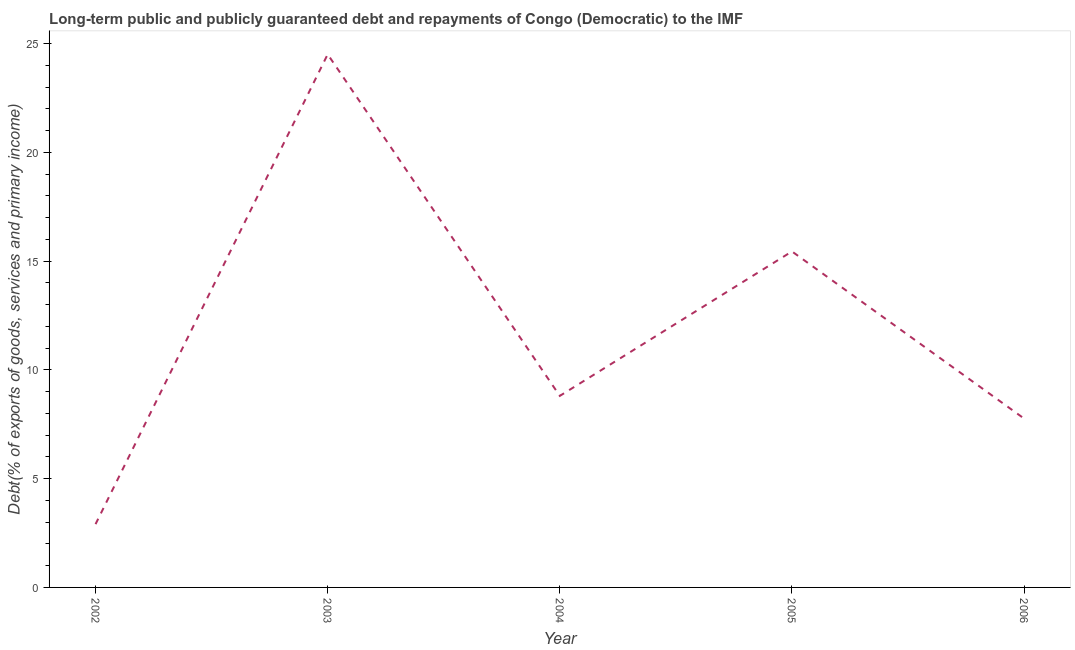What is the debt service in 2004?
Your answer should be very brief. 8.8. Across all years, what is the maximum debt service?
Offer a very short reply. 24.51. Across all years, what is the minimum debt service?
Keep it short and to the point. 2.91. In which year was the debt service maximum?
Your response must be concise. 2003. In which year was the debt service minimum?
Your response must be concise. 2002. What is the sum of the debt service?
Your answer should be compact. 59.43. What is the difference between the debt service in 2002 and 2004?
Offer a very short reply. -5.9. What is the average debt service per year?
Keep it short and to the point. 11.89. What is the median debt service?
Offer a very short reply. 8.8. In how many years, is the debt service greater than 3 %?
Your response must be concise. 4. Do a majority of the years between 2006 and 2002 (inclusive) have debt service greater than 4 %?
Provide a succinct answer. Yes. What is the ratio of the debt service in 2002 to that in 2006?
Your answer should be compact. 0.37. What is the difference between the highest and the second highest debt service?
Your answer should be very brief. 9.06. What is the difference between the highest and the lowest debt service?
Make the answer very short. 21.6. In how many years, is the debt service greater than the average debt service taken over all years?
Give a very brief answer. 2. Does the debt service monotonically increase over the years?
Keep it short and to the point. No. How many years are there in the graph?
Offer a very short reply. 5. What is the difference between two consecutive major ticks on the Y-axis?
Your answer should be compact. 5. Does the graph contain grids?
Make the answer very short. No. What is the title of the graph?
Your answer should be compact. Long-term public and publicly guaranteed debt and repayments of Congo (Democratic) to the IMF. What is the label or title of the Y-axis?
Keep it short and to the point. Debt(% of exports of goods, services and primary income). What is the Debt(% of exports of goods, services and primary income) in 2002?
Offer a very short reply. 2.91. What is the Debt(% of exports of goods, services and primary income) in 2003?
Your answer should be very brief. 24.51. What is the Debt(% of exports of goods, services and primary income) of 2004?
Your answer should be compact. 8.8. What is the Debt(% of exports of goods, services and primary income) in 2005?
Keep it short and to the point. 15.45. What is the Debt(% of exports of goods, services and primary income) of 2006?
Ensure brevity in your answer.  7.76. What is the difference between the Debt(% of exports of goods, services and primary income) in 2002 and 2003?
Provide a succinct answer. -21.6. What is the difference between the Debt(% of exports of goods, services and primary income) in 2002 and 2004?
Make the answer very short. -5.9. What is the difference between the Debt(% of exports of goods, services and primary income) in 2002 and 2005?
Keep it short and to the point. -12.54. What is the difference between the Debt(% of exports of goods, services and primary income) in 2002 and 2006?
Give a very brief answer. -4.85. What is the difference between the Debt(% of exports of goods, services and primary income) in 2003 and 2004?
Your answer should be very brief. 15.7. What is the difference between the Debt(% of exports of goods, services and primary income) in 2003 and 2005?
Make the answer very short. 9.06. What is the difference between the Debt(% of exports of goods, services and primary income) in 2003 and 2006?
Provide a succinct answer. 16.74. What is the difference between the Debt(% of exports of goods, services and primary income) in 2004 and 2005?
Keep it short and to the point. -6.64. What is the difference between the Debt(% of exports of goods, services and primary income) in 2004 and 2006?
Your answer should be compact. 1.04. What is the difference between the Debt(% of exports of goods, services and primary income) in 2005 and 2006?
Give a very brief answer. 7.68. What is the ratio of the Debt(% of exports of goods, services and primary income) in 2002 to that in 2003?
Your answer should be very brief. 0.12. What is the ratio of the Debt(% of exports of goods, services and primary income) in 2002 to that in 2004?
Your answer should be very brief. 0.33. What is the ratio of the Debt(% of exports of goods, services and primary income) in 2002 to that in 2005?
Your answer should be compact. 0.19. What is the ratio of the Debt(% of exports of goods, services and primary income) in 2002 to that in 2006?
Provide a short and direct response. 0.38. What is the ratio of the Debt(% of exports of goods, services and primary income) in 2003 to that in 2004?
Your response must be concise. 2.78. What is the ratio of the Debt(% of exports of goods, services and primary income) in 2003 to that in 2005?
Your response must be concise. 1.59. What is the ratio of the Debt(% of exports of goods, services and primary income) in 2003 to that in 2006?
Ensure brevity in your answer.  3.16. What is the ratio of the Debt(% of exports of goods, services and primary income) in 2004 to that in 2005?
Ensure brevity in your answer.  0.57. What is the ratio of the Debt(% of exports of goods, services and primary income) in 2004 to that in 2006?
Make the answer very short. 1.13. What is the ratio of the Debt(% of exports of goods, services and primary income) in 2005 to that in 2006?
Provide a succinct answer. 1.99. 